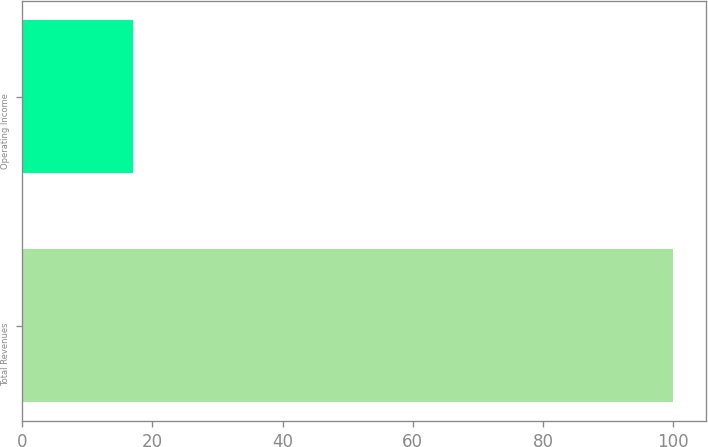<chart> <loc_0><loc_0><loc_500><loc_500><bar_chart><fcel>Total Revenues<fcel>Operating Income<nl><fcel>100<fcel>17<nl></chart> 